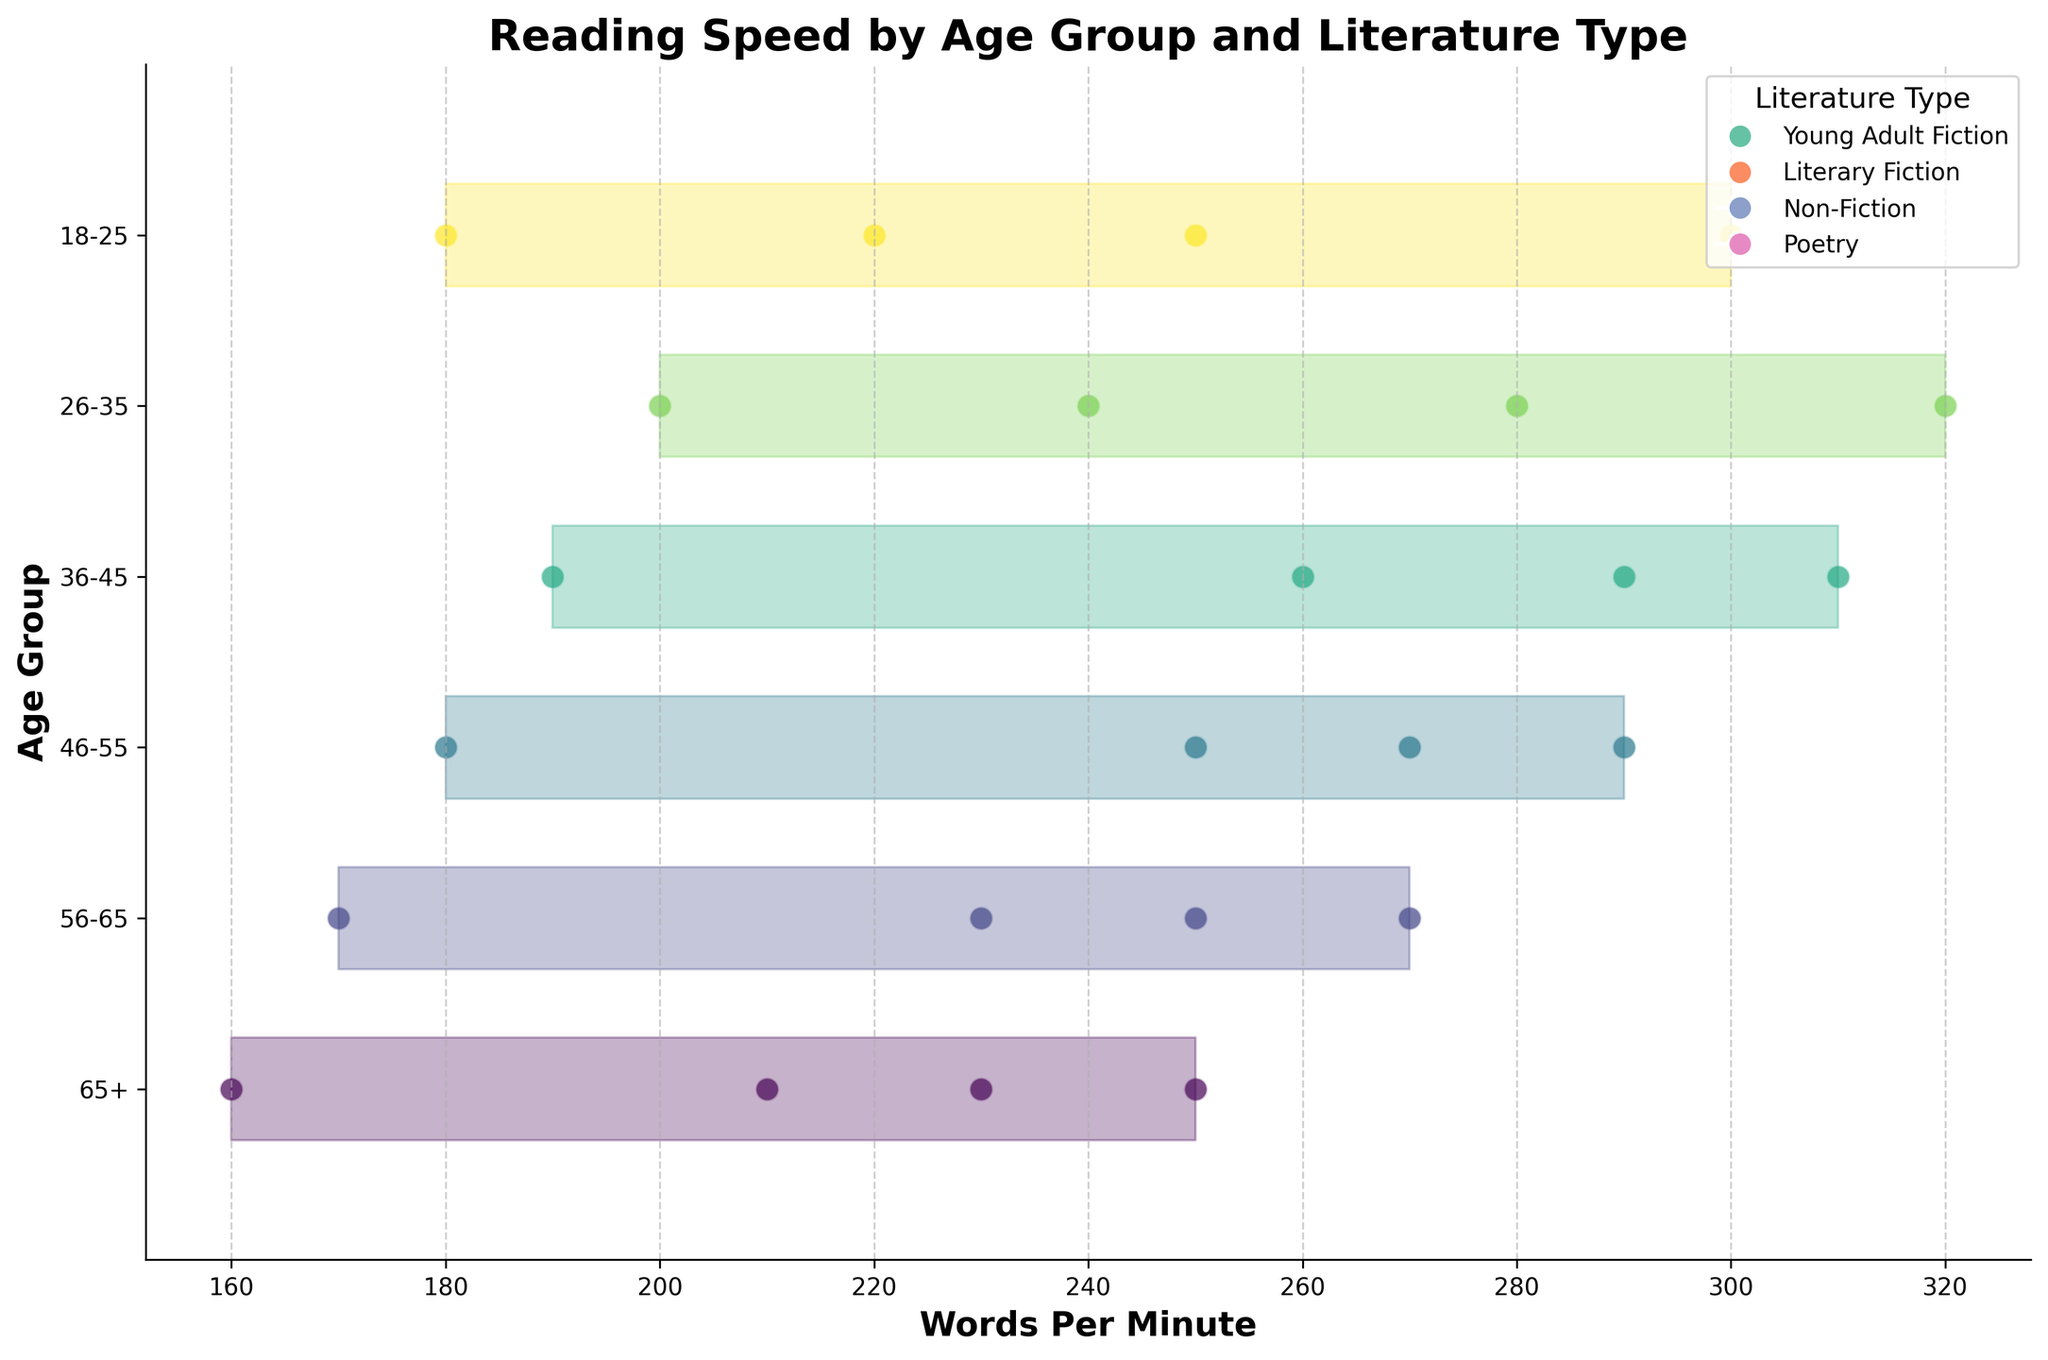What's the title of the figure? The title is displayed at the top center of the figure. It describes the main subject of the plot.
Answer: Reading Speed by Age Group and Literature Type How many age groups are represented in the figure? The age groups can be observed along the y-axis, with each unique label corresponding to a different age group.
Answer: 6 Which age group reads at the highest words per minute for Young Adult Fiction? Identify the words per minute values specific to the literature type "Young Adult Fiction" and find the maximum value along the horizontal axis for each age group.
Answer: 26-35 Comparing Non-Fiction reading speeds, which age group has the slowest speed? Identify the words per minute values specific to the literature type "Non-Fiction" and find the minimum value along the horizontal axis for each age group.
Answer: 65+ What is the difference in reading speed for Poetry between the age groups 18-25 and 26-35? Subtract the words per minute value for Poetry in the age group 18-25 from that of the age group 26-35.
Answer: 20 Which literature type has the largest change in reading speed from the age group 18-25 to 65+? Calculate the change in reading speed for each literature type by subtracting the values for the age group 65+ from those of the age group 18-25 and compare the resulting changes.
Answer: Young Adult Fiction Are there any age groups where the reading speeds for NDifferent literature types appear tightly clustered together? Check the spread of words per minute values for different literature types within each age group; tight clustering indicates minimal spread.
Answer: 65+ What pattern can be observed in the reading speeds of Young Adult Fiction across different age groups? Observe the trend of reading speeds for Young Adult Fiction across the age groups from youngest to oldest.
Answer: Generally decreases with age How do the reading speeds of Literary Fiction compare to Non-Fiction for the age group 36-45? Identify the words per minute values for Literary Fiction and Non-Fiction within the 36-45 age group and compare them.
Answer: Literary Fiction is faster by 30 words per minute 